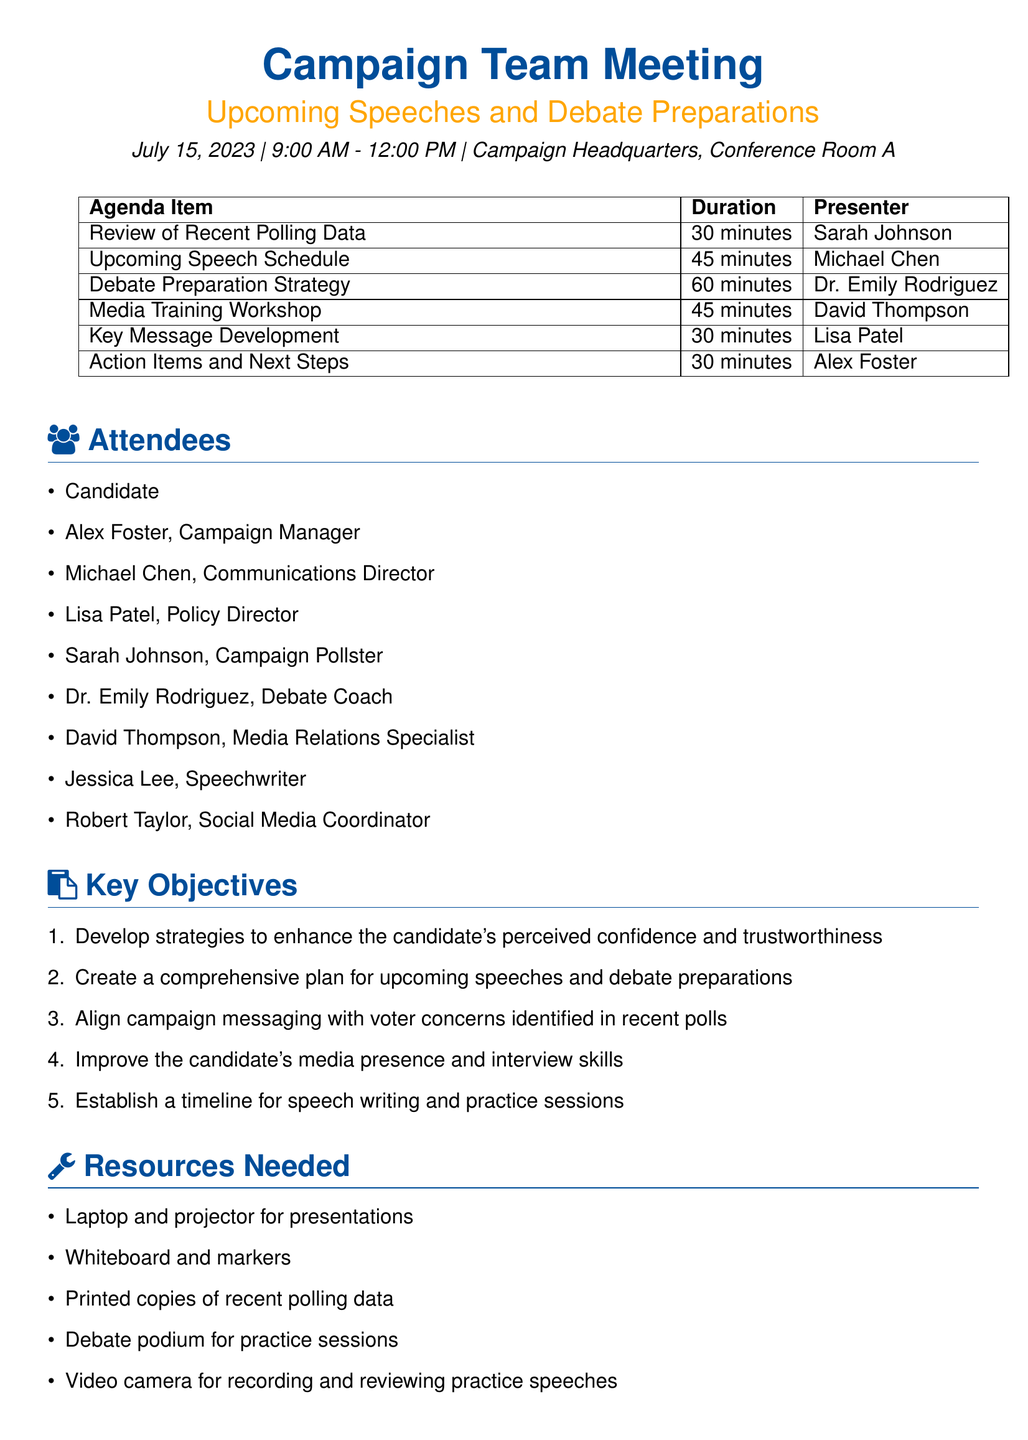What is the date of the meeting? The date of the meeting is explicitly stated in the meeting details section of the document.
Answer: July 15, 2023 Who is the presenter for the "Media Training Workshop"? The presenter's name for each agenda item is listed in the agenda items section.
Answer: David Thompson How long is the "Debate Preparation Strategy" scheduled for? The duration for each agenda item is clearly outlined in the agenda items section.
Answer: 60 minutes What are the key objectives related to media presence? By reading through the key objectives, one can find the specific focus on improving media presence.
Answer: Improve the candidate's media presence and interview skills Which room will the meeting take place in? The specific location of the meeting is mentioned in the meeting details section.
Answer: Conference Room A Who is responsible for the "Action Items and Next Steps"? Each agenda item lists a presenter who is responsible for that item, as indicated in the agenda items.
Answer: Alex Foster 